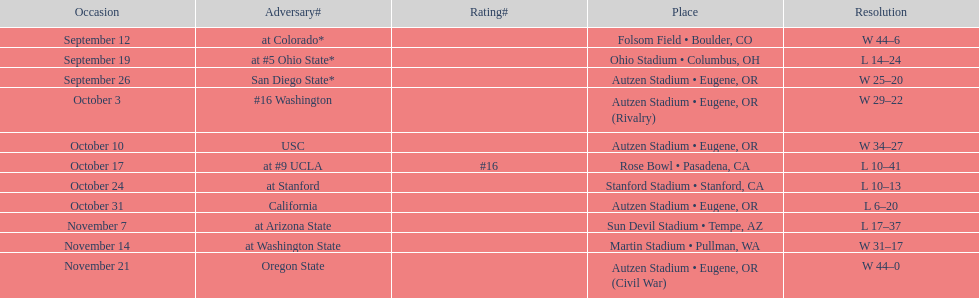Did the team win or lose more games? Win. 